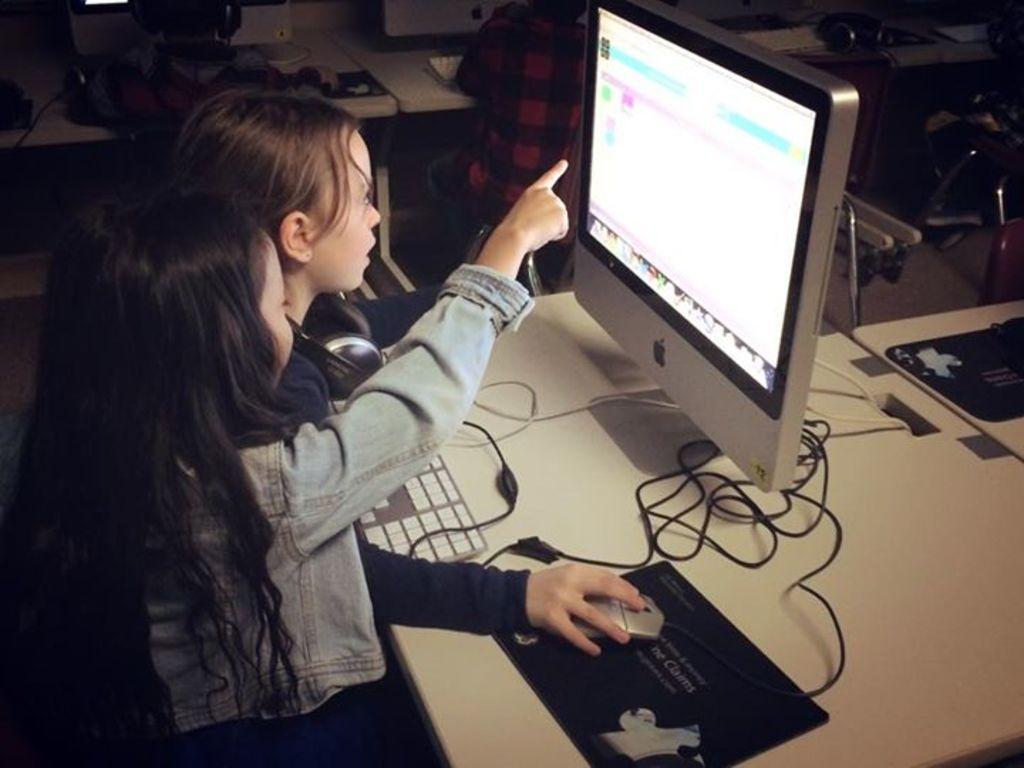Describe this image in one or two sentences. There are two girls and she is holding a mouse. We can see monitor, mouse pads, mouse, keyboard and cables on tables. In the background there are kids sitting and we can see monitors and objects on tables. 